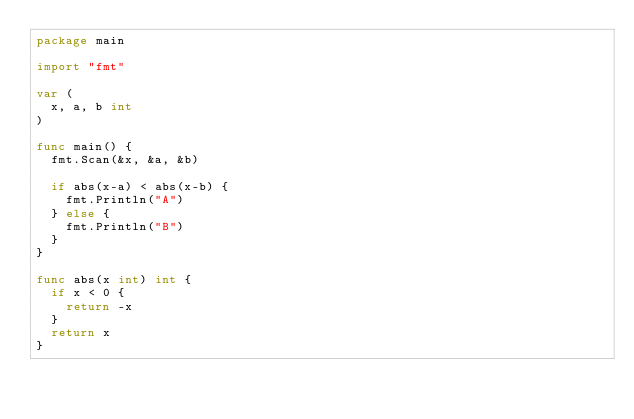<code> <loc_0><loc_0><loc_500><loc_500><_Go_>package main

import "fmt"

var (
	x, a, b int
)

func main() {
	fmt.Scan(&x, &a, &b)

	if abs(x-a) < abs(x-b) {
		fmt.Println("A")
	} else {
		fmt.Println("B")
	}
}

func abs(x int) int {
	if x < 0 {
		return -x
	}
	return x
}
</code> 